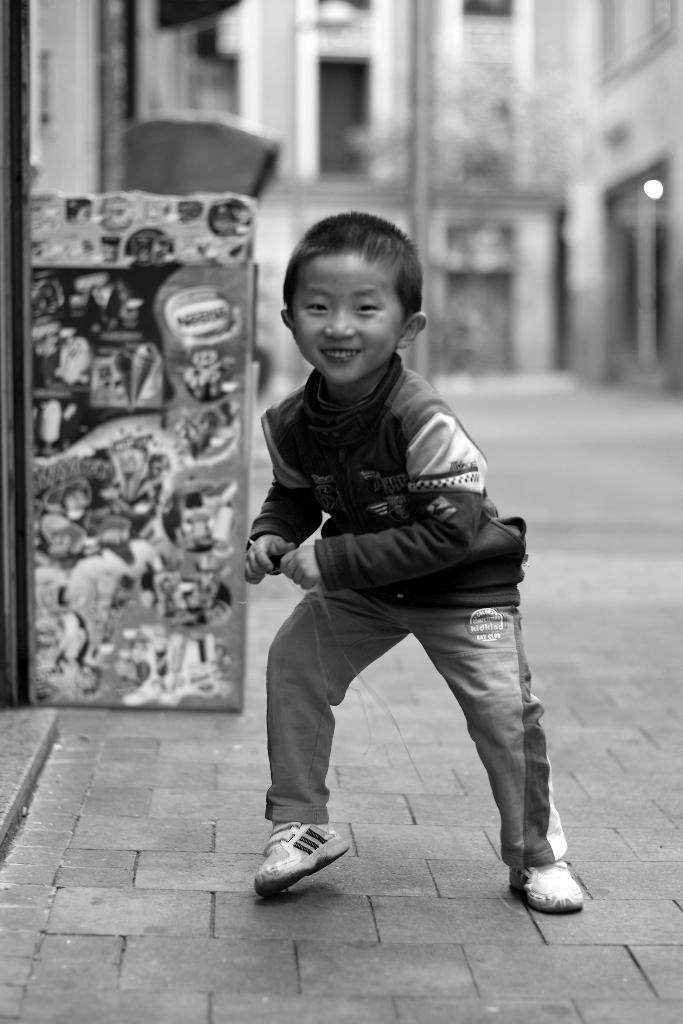Could you give a brief overview of what you see in this image? This is a black and white image, We can see there is one kid standing on the ground in the middle of this image and there is a building in the background. 